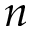Convert formula to latex. <formula><loc_0><loc_0><loc_500><loc_500>n</formula> 